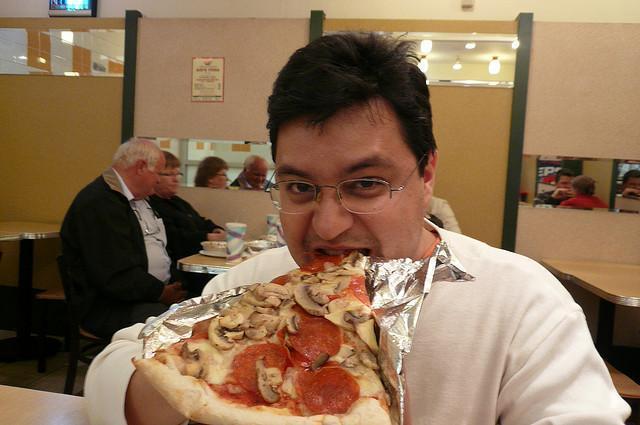How many dining tables are there?
Give a very brief answer. 3. How many people can be seen?
Give a very brief answer. 3. How many chairs are there?
Give a very brief answer. 2. 